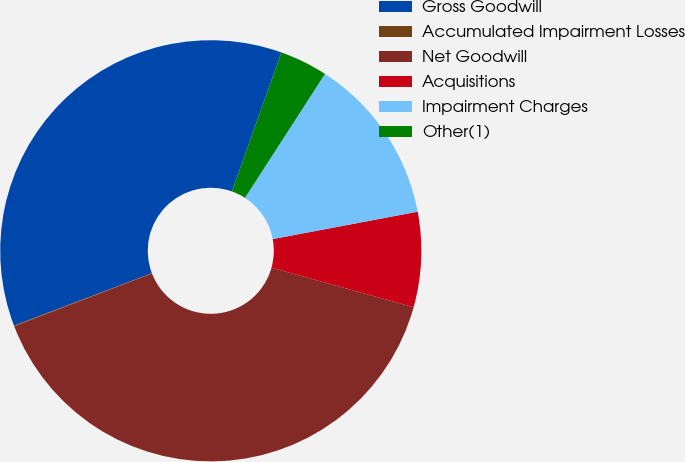Convert chart to OTSL. <chart><loc_0><loc_0><loc_500><loc_500><pie_chart><fcel>Gross Goodwill<fcel>Accumulated Impairment Losses<fcel>Net Goodwill<fcel>Acquisitions<fcel>Impairment Charges<fcel>Other(1)<nl><fcel>36.22%<fcel>0.06%<fcel>39.84%<fcel>7.29%<fcel>12.9%<fcel>3.68%<nl></chart> 